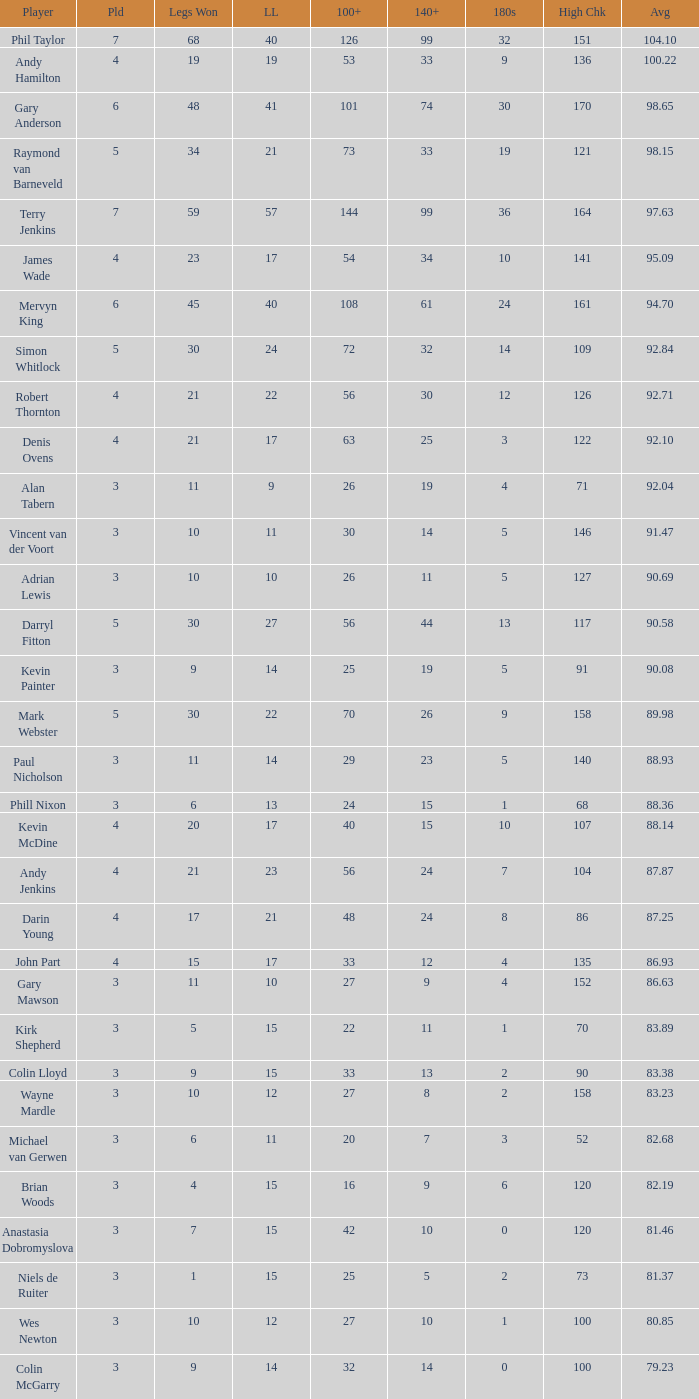What is the number of high checkout when legs Lost is 17, 140+ is 15, and played is larger than 4? None. 